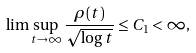Convert formula to latex. <formula><loc_0><loc_0><loc_500><loc_500>\lim \sup _ { t \rightarrow \infty } \frac { \rho ( t ) } { \sqrt { \log t } } \leq C _ { 1 } < \infty ,</formula> 